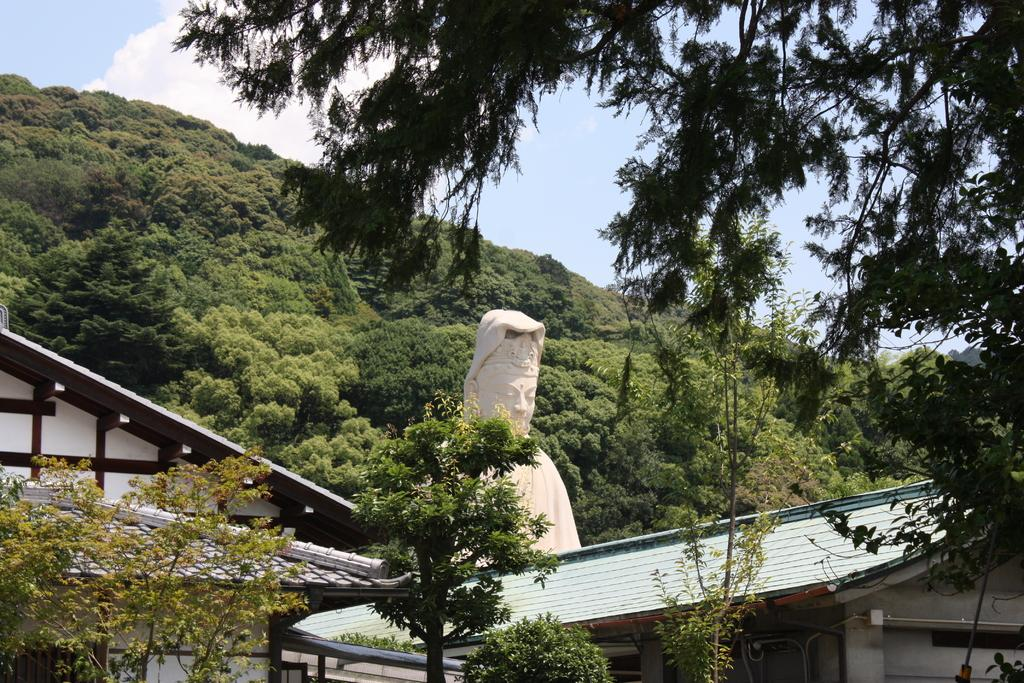What type of structures can be seen in the image? There are buildings in the image. What other natural elements are present in the image? There are trees in the image. Are there any artistic features in the image? Yes, there is a sculpture in the image. What can be seen in the background of the image? The sky is visible in the background of the image. What is the condition of the sky in the image? Clouds are present in the sky. How many babies are playing baseball in the image? There are no babies or baseball activity present in the image. What type of brass instrument is featured in the sculpture? The image does not show a sculpture with a brass instrument; it only mentions a sculpture in general. 